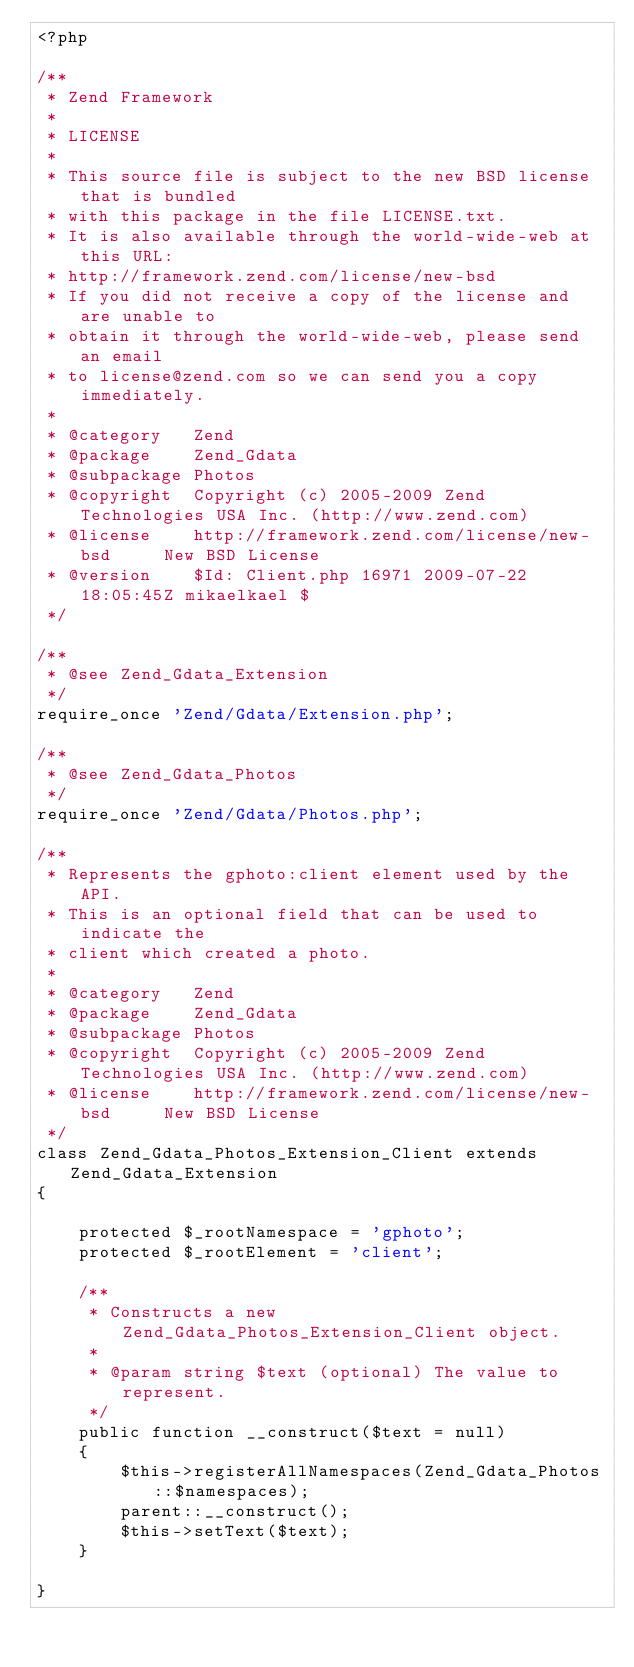<code> <loc_0><loc_0><loc_500><loc_500><_PHP_><?php

/**
 * Zend Framework
 *
 * LICENSE
 *
 * This source file is subject to the new BSD license that is bundled
 * with this package in the file LICENSE.txt.
 * It is also available through the world-wide-web at this URL:
 * http://framework.zend.com/license/new-bsd
 * If you did not receive a copy of the license and are unable to
 * obtain it through the world-wide-web, please send an email
 * to license@zend.com so we can send you a copy immediately.
 *
 * @category   Zend
 * @package    Zend_Gdata
 * @subpackage Photos
 * @copyright  Copyright (c) 2005-2009 Zend Technologies USA Inc. (http://www.zend.com)
 * @license    http://framework.zend.com/license/new-bsd     New BSD License
 * @version    $Id: Client.php 16971 2009-07-22 18:05:45Z mikaelkael $
 */

/**
 * @see Zend_Gdata_Extension
 */
require_once 'Zend/Gdata/Extension.php';

/**
 * @see Zend_Gdata_Photos
 */
require_once 'Zend/Gdata/Photos.php';

/**
 * Represents the gphoto:client element used by the API.
 * This is an optional field that can be used to indicate the
 * client which created a photo.
 *
 * @category   Zend
 * @package    Zend_Gdata
 * @subpackage Photos
 * @copyright  Copyright (c) 2005-2009 Zend Technologies USA Inc. (http://www.zend.com)
 * @license    http://framework.zend.com/license/new-bsd     New BSD License
 */
class Zend_Gdata_Photos_Extension_Client extends Zend_Gdata_Extension
{

    protected $_rootNamespace = 'gphoto';
    protected $_rootElement = 'client';

    /**
     * Constructs a new Zend_Gdata_Photos_Extension_Client object.
     *
     * @param string $text (optional) The value to represent.
     */
    public function __construct($text = null)
    {
        $this->registerAllNamespaces(Zend_Gdata_Photos::$namespaces);
        parent::__construct();
        $this->setText($text);
    }

}
</code> 